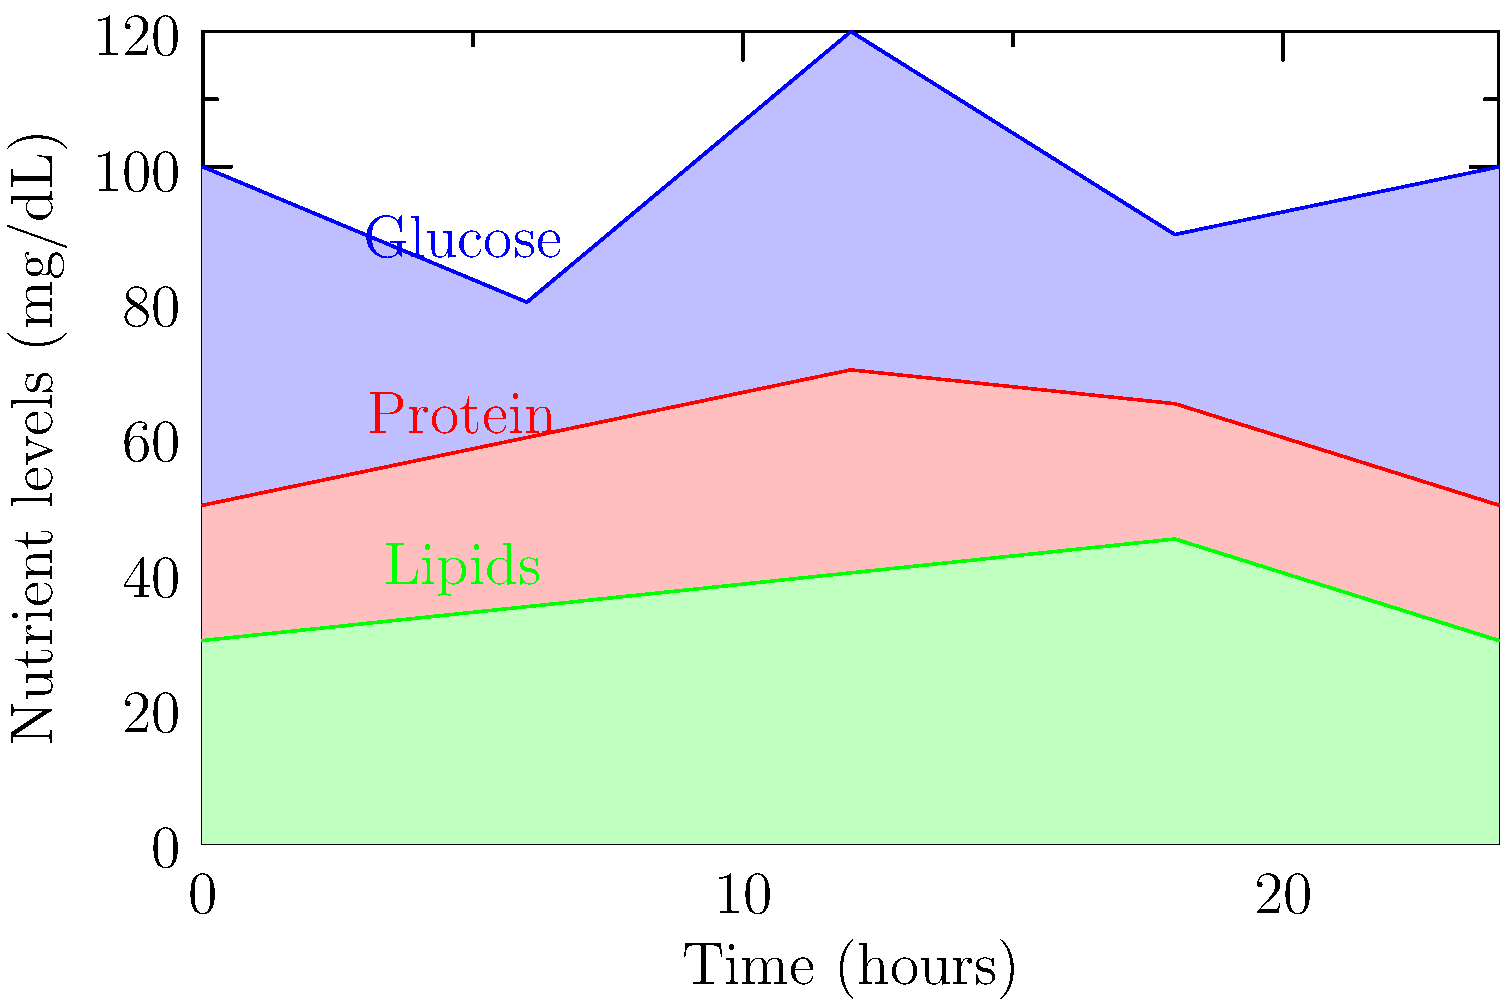Based on the stacked area chart showing nutrient levels in the blood over a 24-hour period, which nutrient shows the highest peak and at approximately what time does this occur? To answer this question, we need to analyze the stacked area chart carefully:

1. The chart shows three nutrients: Glucose (blue), Protein (red), and Lipids (green).
2. We need to identify the highest point on any of these curves.
3. Examining the glucose curve (blue):
   - It starts at 100 mg/dL
   - Dips to about 80 mg/dL at 6 hours
   - Rises to its peak of about 120 mg/dL at 12 hours
   - Decreases to about 90 mg/dL at 18 hours
   - Returns to 100 mg/dL at 24 hours
4. The protein curve (red) peaks at about 70 mg/dL at 12 hours.
5. The lipids curve (green) gradually increases to about 45 mg/dL at 18 hours.
6. Comparing these peaks, we can see that glucose has the highest peak at approximately 120 mg/dL.
7. This peak occurs at the 12-hour mark on the time axis.

Therefore, glucose shows the highest peak, occurring at approximately 12 hours.
Answer: Glucose, at approximately 12 hours 